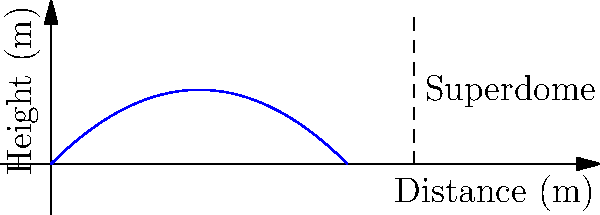At the Superdome, a football is thrown with an initial velocity of 20 m/s at an angle of 45° above the horizontal. Ignoring air resistance, what is the maximum height reached by the football? To find the maximum height reached by the football, we can follow these steps:

1) The vertical component of the initial velocity is given by:
   $v_y = v_0 \sin(\theta) = 20 \cdot \sin(45°) = 20 \cdot \frac{\sqrt{2}}{2} \approx 14.14$ m/s

2) The time to reach the maximum height can be calculated using:
   $t_{max} = \frac{v_y}{g}$, where $g = 9.8$ m/s²
   $t_{max} = \frac{14.14}{9.8} \approx 1.44$ seconds

3) The maximum height can be calculated using the equation:
   $h_{max} = v_y t - \frac{1}{2}gt^2$

4) Substituting the values:
   $h_{max} = 14.14 \cdot 1.44 - \frac{1}{2} \cdot 9.8 \cdot 1.44^2$
   $h_{max} = 20.36 - 10.18 = 10.18$ meters

Therefore, the maximum height reached by the football is approximately 10.18 meters.
Answer: 10.18 meters 